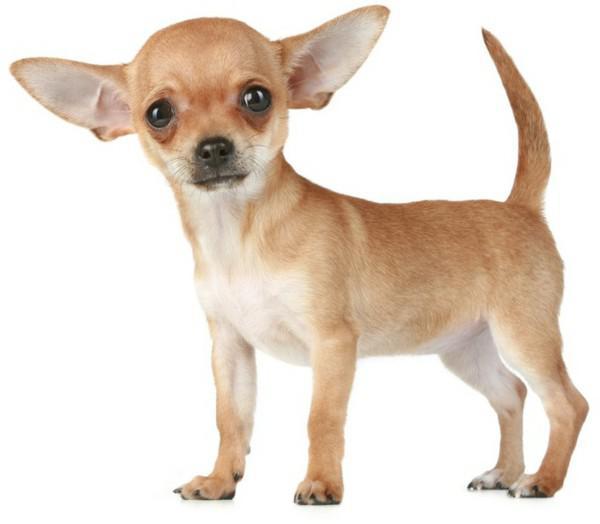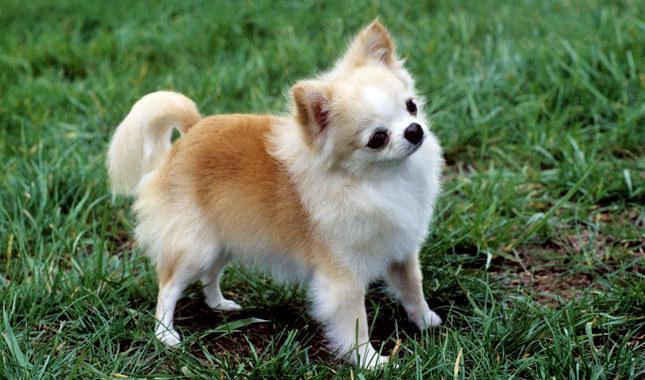The first image is the image on the left, the second image is the image on the right. Analyze the images presented: Is the assertion "At least one dog is wearing a collar." valid? Answer yes or no. No. 